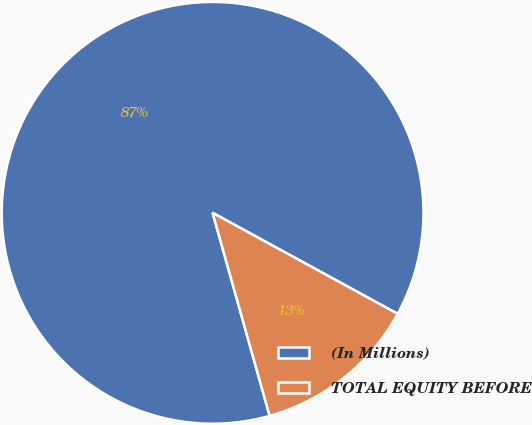Convert chart to OTSL. <chart><loc_0><loc_0><loc_500><loc_500><pie_chart><fcel>(In Millions)<fcel>TOTAL EQUITY BEFORE<nl><fcel>87.31%<fcel>12.69%<nl></chart> 